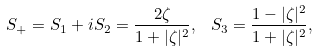<formula> <loc_0><loc_0><loc_500><loc_500>S _ { + } = S _ { 1 } + i S _ { 2 } = \frac { 2 \zeta } { 1 + | \zeta | ^ { 2 } } , \, \ S _ { 3 } = \frac { 1 - | \zeta | ^ { 2 } } { 1 + | \zeta | ^ { 2 } } ,</formula> 